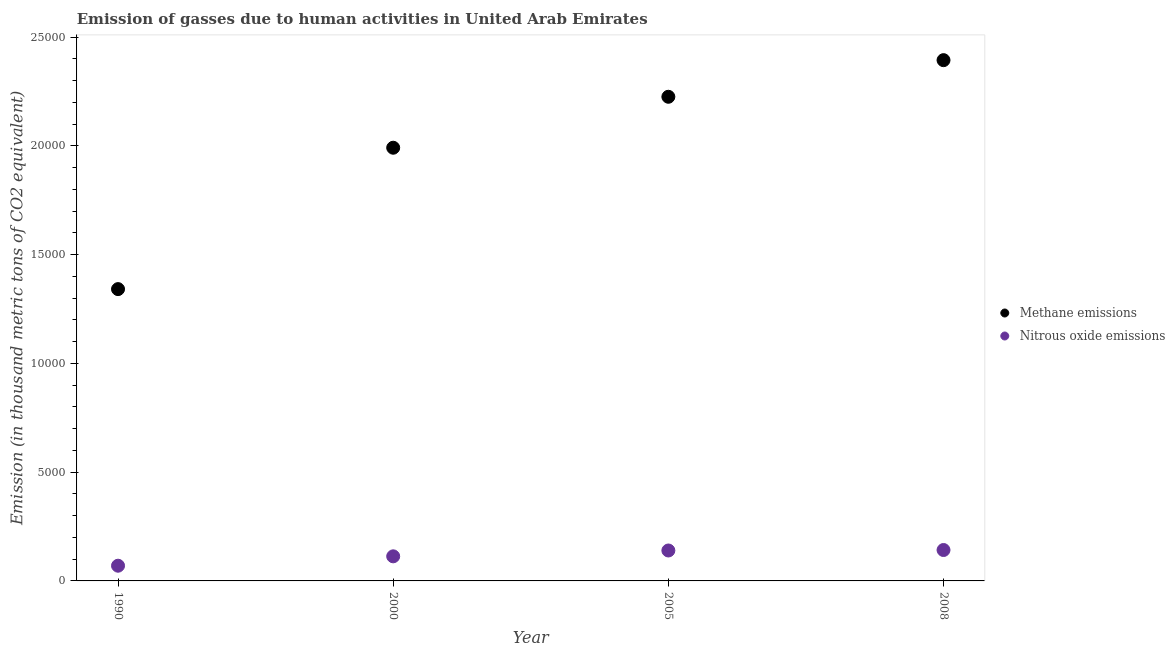How many different coloured dotlines are there?
Provide a succinct answer. 2. What is the amount of methane emissions in 1990?
Your answer should be very brief. 1.34e+04. Across all years, what is the maximum amount of methane emissions?
Ensure brevity in your answer.  2.39e+04. Across all years, what is the minimum amount of methane emissions?
Offer a very short reply. 1.34e+04. In which year was the amount of methane emissions maximum?
Offer a very short reply. 2008. In which year was the amount of nitrous oxide emissions minimum?
Offer a terse response. 1990. What is the total amount of methane emissions in the graph?
Make the answer very short. 7.95e+04. What is the difference between the amount of nitrous oxide emissions in 1990 and that in 2005?
Offer a very short reply. -699.7. What is the difference between the amount of methane emissions in 2000 and the amount of nitrous oxide emissions in 2005?
Offer a terse response. 1.85e+04. What is the average amount of nitrous oxide emissions per year?
Offer a terse response. 1162.27. In the year 2000, what is the difference between the amount of nitrous oxide emissions and amount of methane emissions?
Ensure brevity in your answer.  -1.88e+04. In how many years, is the amount of methane emissions greater than 12000 thousand metric tons?
Make the answer very short. 4. What is the ratio of the amount of nitrous oxide emissions in 2000 to that in 2005?
Offer a very short reply. 0.81. Is the difference between the amount of methane emissions in 1990 and 2005 greater than the difference between the amount of nitrous oxide emissions in 1990 and 2005?
Your answer should be very brief. No. What is the difference between the highest and the second highest amount of methane emissions?
Ensure brevity in your answer.  1683.5. What is the difference between the highest and the lowest amount of nitrous oxide emissions?
Your answer should be very brief. 721.6. In how many years, is the amount of nitrous oxide emissions greater than the average amount of nitrous oxide emissions taken over all years?
Provide a succinct answer. 2. Is the amount of nitrous oxide emissions strictly greater than the amount of methane emissions over the years?
Offer a very short reply. No. Is the amount of methane emissions strictly less than the amount of nitrous oxide emissions over the years?
Make the answer very short. No. Does the graph contain grids?
Keep it short and to the point. No. Where does the legend appear in the graph?
Keep it short and to the point. Center right. How many legend labels are there?
Offer a very short reply. 2. What is the title of the graph?
Ensure brevity in your answer.  Emission of gasses due to human activities in United Arab Emirates. What is the label or title of the X-axis?
Your response must be concise. Year. What is the label or title of the Y-axis?
Give a very brief answer. Emission (in thousand metric tons of CO2 equivalent). What is the Emission (in thousand metric tons of CO2 equivalent) in Methane emissions in 1990?
Ensure brevity in your answer.  1.34e+04. What is the Emission (in thousand metric tons of CO2 equivalent) of Nitrous oxide emissions in 1990?
Your response must be concise. 699.1. What is the Emission (in thousand metric tons of CO2 equivalent) of Methane emissions in 2000?
Make the answer very short. 1.99e+04. What is the Emission (in thousand metric tons of CO2 equivalent) in Nitrous oxide emissions in 2000?
Your answer should be very brief. 1130.5. What is the Emission (in thousand metric tons of CO2 equivalent) of Methane emissions in 2005?
Provide a succinct answer. 2.23e+04. What is the Emission (in thousand metric tons of CO2 equivalent) in Nitrous oxide emissions in 2005?
Provide a succinct answer. 1398.8. What is the Emission (in thousand metric tons of CO2 equivalent) of Methane emissions in 2008?
Make the answer very short. 2.39e+04. What is the Emission (in thousand metric tons of CO2 equivalent) of Nitrous oxide emissions in 2008?
Keep it short and to the point. 1420.7. Across all years, what is the maximum Emission (in thousand metric tons of CO2 equivalent) of Methane emissions?
Make the answer very short. 2.39e+04. Across all years, what is the maximum Emission (in thousand metric tons of CO2 equivalent) in Nitrous oxide emissions?
Provide a short and direct response. 1420.7. Across all years, what is the minimum Emission (in thousand metric tons of CO2 equivalent) of Methane emissions?
Give a very brief answer. 1.34e+04. Across all years, what is the minimum Emission (in thousand metric tons of CO2 equivalent) of Nitrous oxide emissions?
Provide a short and direct response. 699.1. What is the total Emission (in thousand metric tons of CO2 equivalent) of Methane emissions in the graph?
Your response must be concise. 7.95e+04. What is the total Emission (in thousand metric tons of CO2 equivalent) of Nitrous oxide emissions in the graph?
Keep it short and to the point. 4649.1. What is the difference between the Emission (in thousand metric tons of CO2 equivalent) in Methane emissions in 1990 and that in 2000?
Provide a short and direct response. -6499. What is the difference between the Emission (in thousand metric tons of CO2 equivalent) of Nitrous oxide emissions in 1990 and that in 2000?
Ensure brevity in your answer.  -431.4. What is the difference between the Emission (in thousand metric tons of CO2 equivalent) in Methane emissions in 1990 and that in 2005?
Your answer should be compact. -8841.4. What is the difference between the Emission (in thousand metric tons of CO2 equivalent) of Nitrous oxide emissions in 1990 and that in 2005?
Offer a very short reply. -699.7. What is the difference between the Emission (in thousand metric tons of CO2 equivalent) of Methane emissions in 1990 and that in 2008?
Keep it short and to the point. -1.05e+04. What is the difference between the Emission (in thousand metric tons of CO2 equivalent) in Nitrous oxide emissions in 1990 and that in 2008?
Give a very brief answer. -721.6. What is the difference between the Emission (in thousand metric tons of CO2 equivalent) in Methane emissions in 2000 and that in 2005?
Make the answer very short. -2342.4. What is the difference between the Emission (in thousand metric tons of CO2 equivalent) in Nitrous oxide emissions in 2000 and that in 2005?
Your answer should be very brief. -268.3. What is the difference between the Emission (in thousand metric tons of CO2 equivalent) in Methane emissions in 2000 and that in 2008?
Ensure brevity in your answer.  -4025.9. What is the difference between the Emission (in thousand metric tons of CO2 equivalent) of Nitrous oxide emissions in 2000 and that in 2008?
Keep it short and to the point. -290.2. What is the difference between the Emission (in thousand metric tons of CO2 equivalent) of Methane emissions in 2005 and that in 2008?
Give a very brief answer. -1683.5. What is the difference between the Emission (in thousand metric tons of CO2 equivalent) in Nitrous oxide emissions in 2005 and that in 2008?
Give a very brief answer. -21.9. What is the difference between the Emission (in thousand metric tons of CO2 equivalent) of Methane emissions in 1990 and the Emission (in thousand metric tons of CO2 equivalent) of Nitrous oxide emissions in 2000?
Offer a very short reply. 1.23e+04. What is the difference between the Emission (in thousand metric tons of CO2 equivalent) in Methane emissions in 1990 and the Emission (in thousand metric tons of CO2 equivalent) in Nitrous oxide emissions in 2005?
Give a very brief answer. 1.20e+04. What is the difference between the Emission (in thousand metric tons of CO2 equivalent) of Methane emissions in 1990 and the Emission (in thousand metric tons of CO2 equivalent) of Nitrous oxide emissions in 2008?
Offer a terse response. 1.20e+04. What is the difference between the Emission (in thousand metric tons of CO2 equivalent) of Methane emissions in 2000 and the Emission (in thousand metric tons of CO2 equivalent) of Nitrous oxide emissions in 2005?
Provide a succinct answer. 1.85e+04. What is the difference between the Emission (in thousand metric tons of CO2 equivalent) of Methane emissions in 2000 and the Emission (in thousand metric tons of CO2 equivalent) of Nitrous oxide emissions in 2008?
Provide a short and direct response. 1.85e+04. What is the difference between the Emission (in thousand metric tons of CO2 equivalent) of Methane emissions in 2005 and the Emission (in thousand metric tons of CO2 equivalent) of Nitrous oxide emissions in 2008?
Ensure brevity in your answer.  2.08e+04. What is the average Emission (in thousand metric tons of CO2 equivalent) in Methane emissions per year?
Your answer should be very brief. 1.99e+04. What is the average Emission (in thousand metric tons of CO2 equivalent) in Nitrous oxide emissions per year?
Give a very brief answer. 1162.28. In the year 1990, what is the difference between the Emission (in thousand metric tons of CO2 equivalent) in Methane emissions and Emission (in thousand metric tons of CO2 equivalent) in Nitrous oxide emissions?
Your response must be concise. 1.27e+04. In the year 2000, what is the difference between the Emission (in thousand metric tons of CO2 equivalent) in Methane emissions and Emission (in thousand metric tons of CO2 equivalent) in Nitrous oxide emissions?
Keep it short and to the point. 1.88e+04. In the year 2005, what is the difference between the Emission (in thousand metric tons of CO2 equivalent) of Methane emissions and Emission (in thousand metric tons of CO2 equivalent) of Nitrous oxide emissions?
Your answer should be compact. 2.09e+04. In the year 2008, what is the difference between the Emission (in thousand metric tons of CO2 equivalent) of Methane emissions and Emission (in thousand metric tons of CO2 equivalent) of Nitrous oxide emissions?
Your answer should be compact. 2.25e+04. What is the ratio of the Emission (in thousand metric tons of CO2 equivalent) of Methane emissions in 1990 to that in 2000?
Offer a very short reply. 0.67. What is the ratio of the Emission (in thousand metric tons of CO2 equivalent) in Nitrous oxide emissions in 1990 to that in 2000?
Your response must be concise. 0.62. What is the ratio of the Emission (in thousand metric tons of CO2 equivalent) in Methane emissions in 1990 to that in 2005?
Your answer should be very brief. 0.6. What is the ratio of the Emission (in thousand metric tons of CO2 equivalent) of Nitrous oxide emissions in 1990 to that in 2005?
Give a very brief answer. 0.5. What is the ratio of the Emission (in thousand metric tons of CO2 equivalent) of Methane emissions in 1990 to that in 2008?
Your answer should be very brief. 0.56. What is the ratio of the Emission (in thousand metric tons of CO2 equivalent) in Nitrous oxide emissions in 1990 to that in 2008?
Make the answer very short. 0.49. What is the ratio of the Emission (in thousand metric tons of CO2 equivalent) in Methane emissions in 2000 to that in 2005?
Offer a terse response. 0.89. What is the ratio of the Emission (in thousand metric tons of CO2 equivalent) in Nitrous oxide emissions in 2000 to that in 2005?
Keep it short and to the point. 0.81. What is the ratio of the Emission (in thousand metric tons of CO2 equivalent) of Methane emissions in 2000 to that in 2008?
Your response must be concise. 0.83. What is the ratio of the Emission (in thousand metric tons of CO2 equivalent) of Nitrous oxide emissions in 2000 to that in 2008?
Your answer should be compact. 0.8. What is the ratio of the Emission (in thousand metric tons of CO2 equivalent) of Methane emissions in 2005 to that in 2008?
Offer a terse response. 0.93. What is the ratio of the Emission (in thousand metric tons of CO2 equivalent) in Nitrous oxide emissions in 2005 to that in 2008?
Give a very brief answer. 0.98. What is the difference between the highest and the second highest Emission (in thousand metric tons of CO2 equivalent) in Methane emissions?
Provide a short and direct response. 1683.5. What is the difference between the highest and the second highest Emission (in thousand metric tons of CO2 equivalent) of Nitrous oxide emissions?
Offer a very short reply. 21.9. What is the difference between the highest and the lowest Emission (in thousand metric tons of CO2 equivalent) in Methane emissions?
Your answer should be compact. 1.05e+04. What is the difference between the highest and the lowest Emission (in thousand metric tons of CO2 equivalent) of Nitrous oxide emissions?
Offer a terse response. 721.6. 